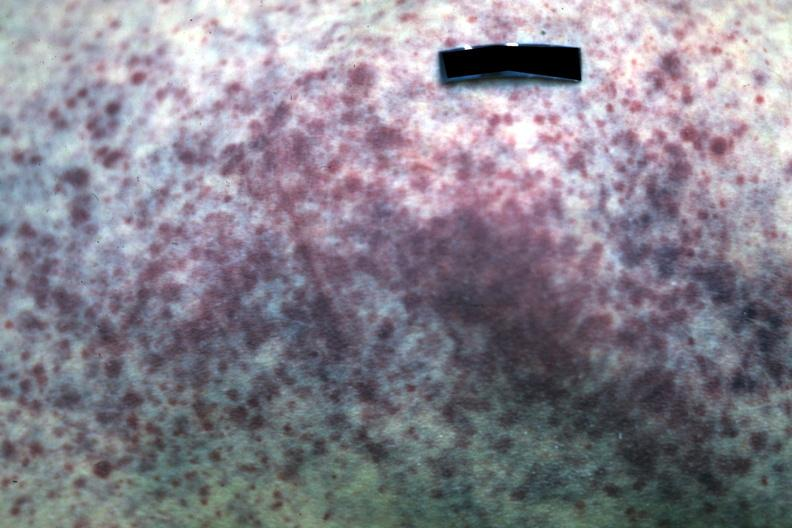what does this image show?
Answer the question using a single word or phrase. Close-up of petechial hemorrhage case of acute myelogenous leukemia 19yo 